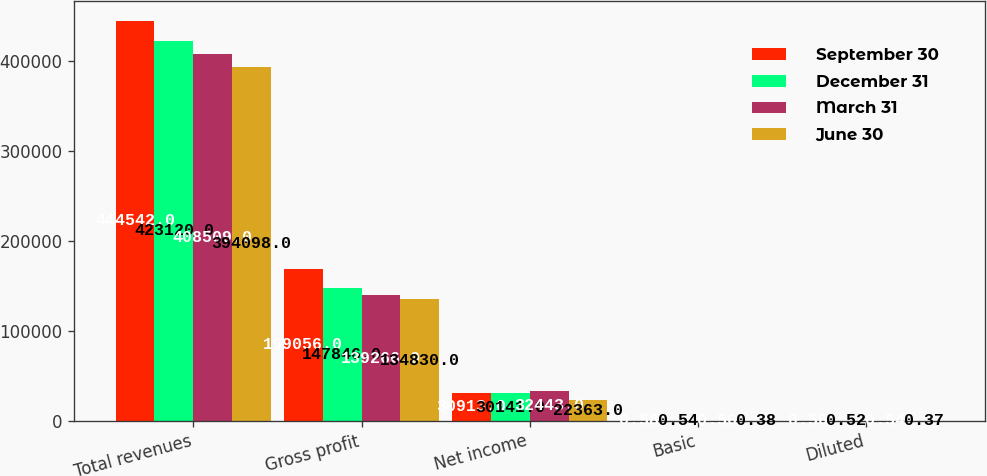Convert chart to OTSL. <chart><loc_0><loc_0><loc_500><loc_500><stacked_bar_chart><ecel><fcel>Total revenues<fcel>Gross profit<fcel>Net income<fcel>Basic<fcel>Diluted<nl><fcel>September 30<fcel>444542<fcel>169056<fcel>30913<fcel>0.58<fcel>0.56<nl><fcel>December 31<fcel>423120<fcel>147846<fcel>30141<fcel>0.54<fcel>0.52<nl><fcel>March 31<fcel>408509<fcel>139266<fcel>32443<fcel>0.56<fcel>0.54<nl><fcel>June 30<fcel>394098<fcel>134830<fcel>22363<fcel>0.38<fcel>0.37<nl></chart> 